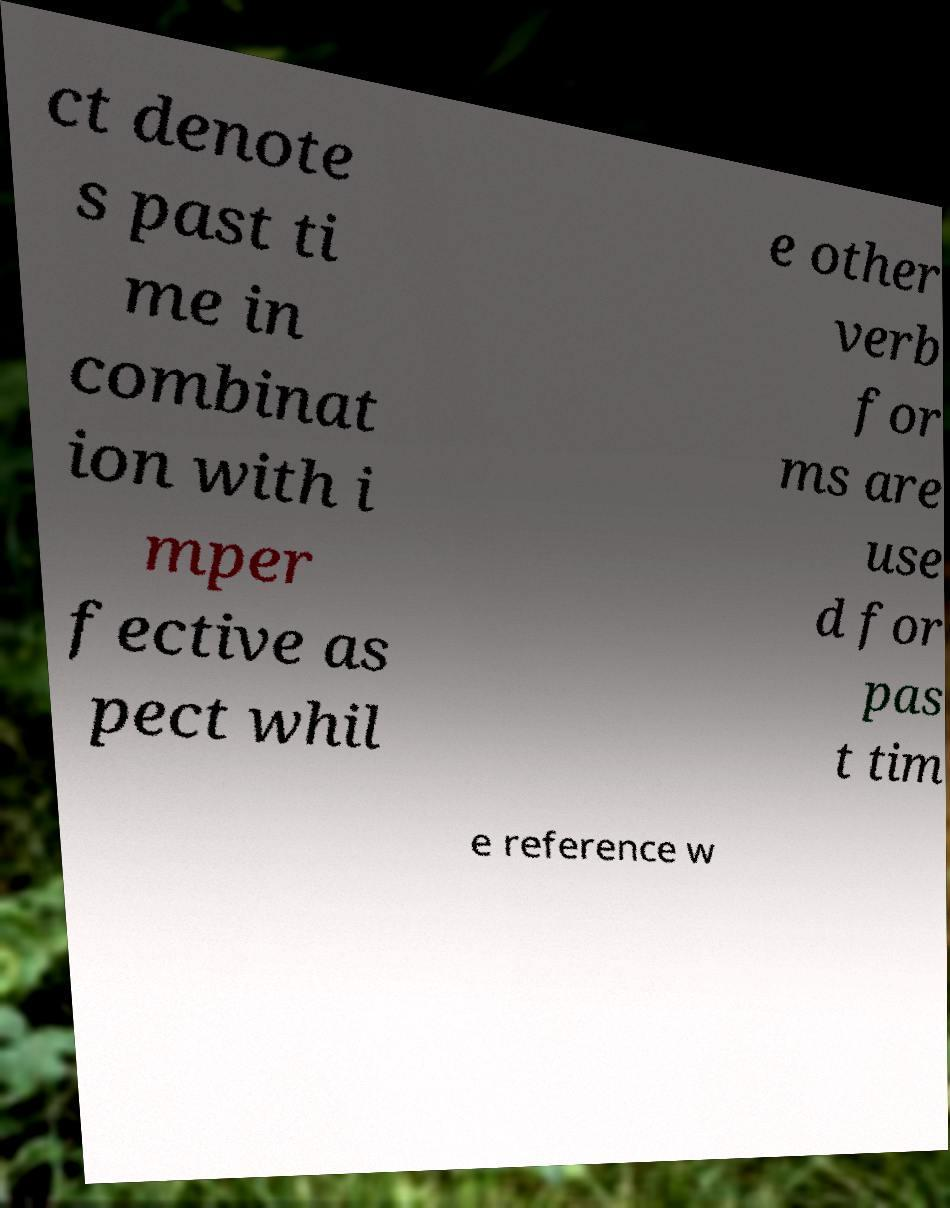Could you assist in decoding the text presented in this image and type it out clearly? ct denote s past ti me in combinat ion with i mper fective as pect whil e other verb for ms are use d for pas t tim e reference w 